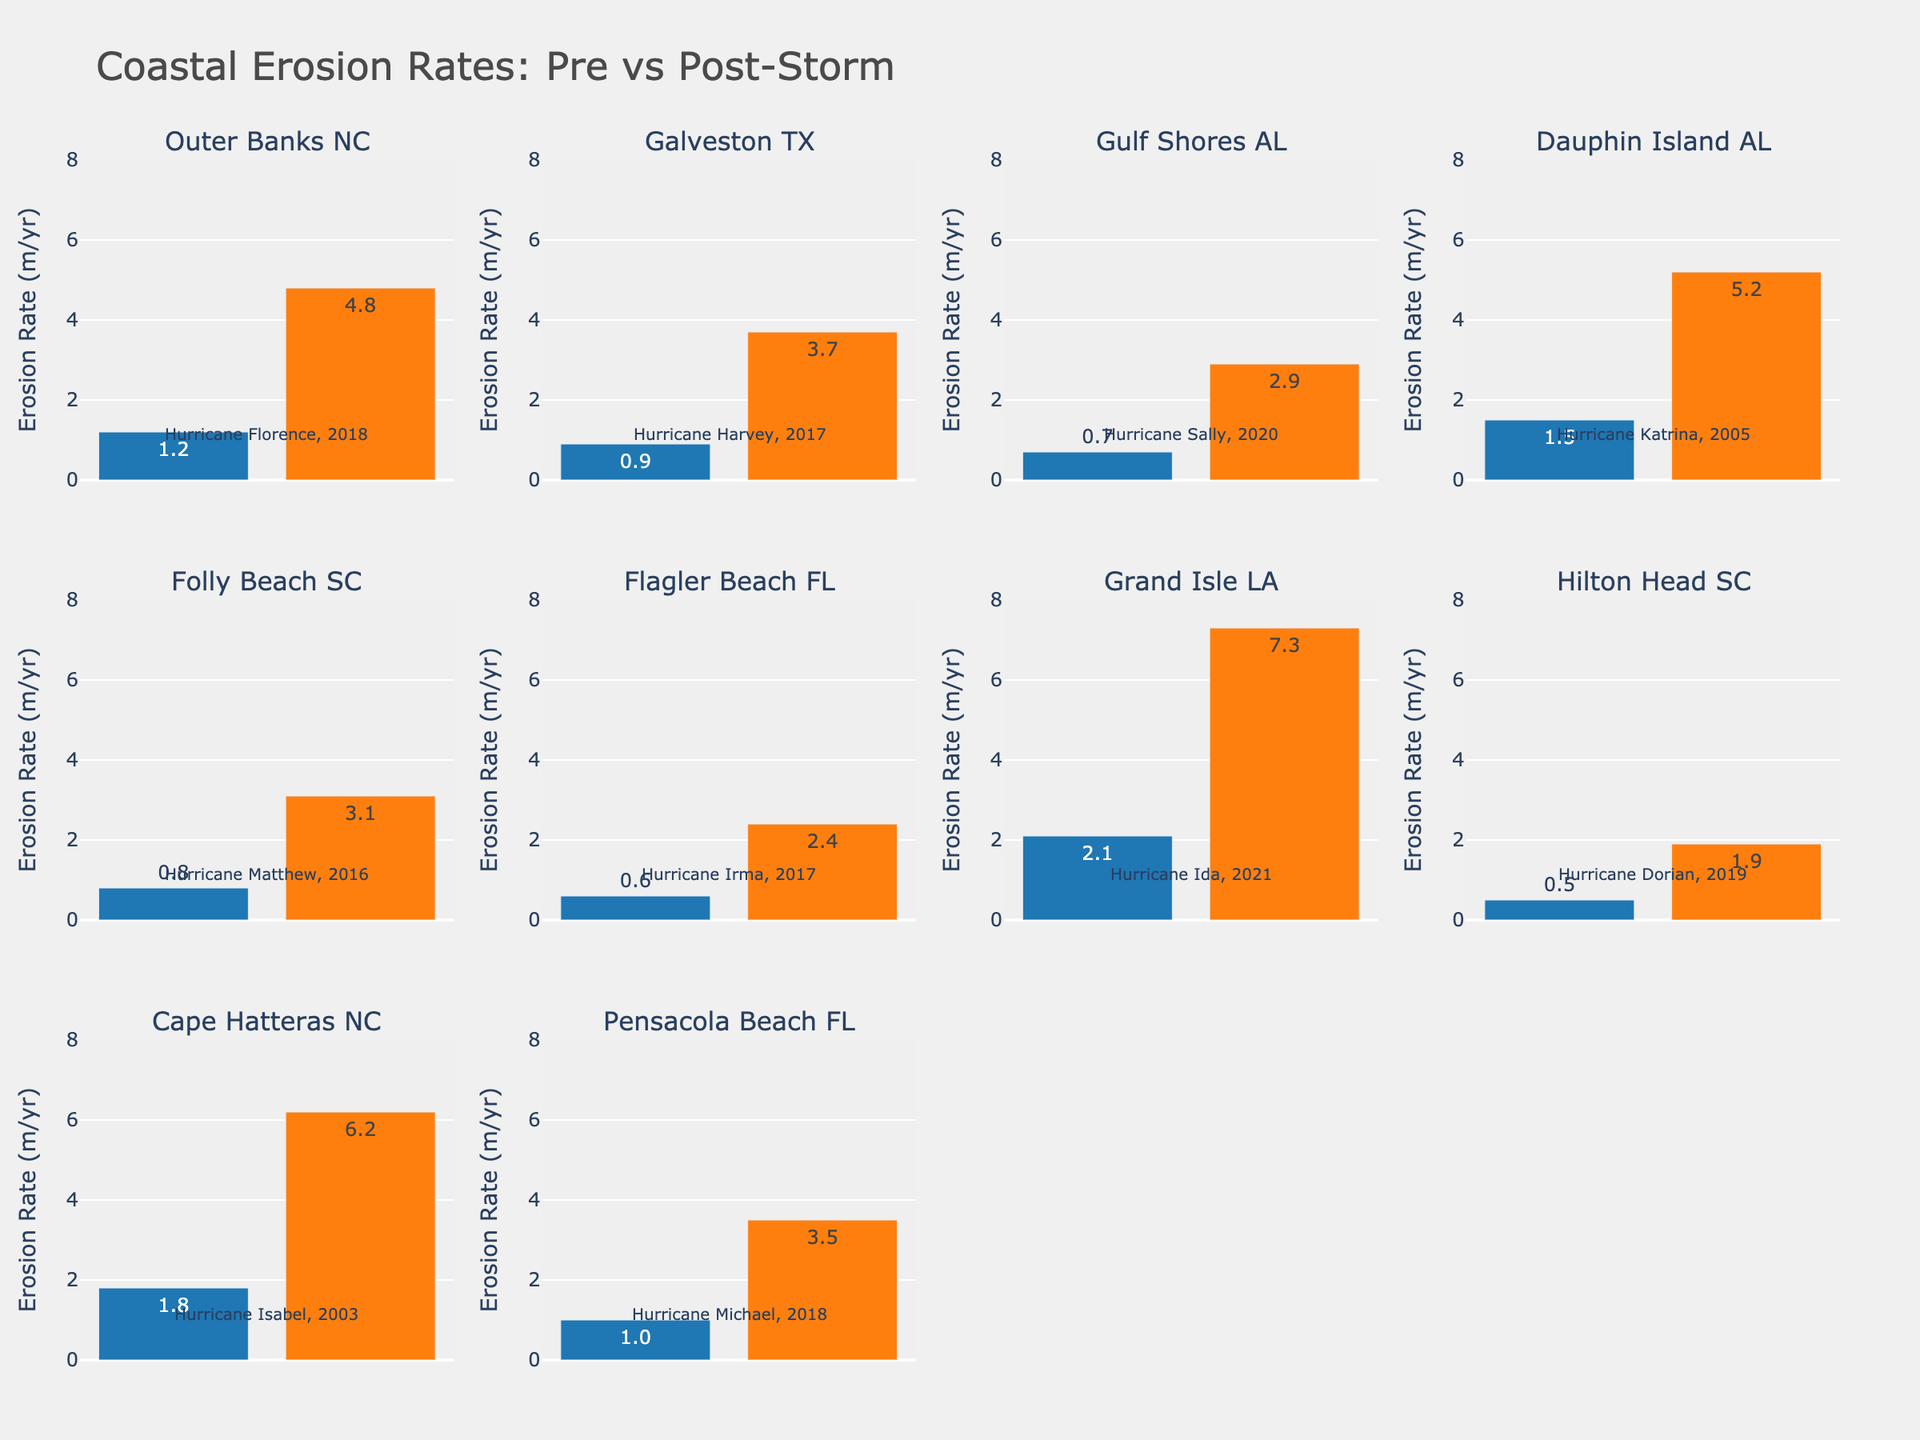Which location shows the highest post-storm erosion rate? Look at the bars representing the post-storm erosion rates in each subplot and identify the tallest bar. Grand Isle, LA shows the highest post-storm erosion rate at 7.3 m/yr.
Answer: Grand Isle, LA What is the average post-storm erosion rate across all locations? Sum all the post-storm erosion rates and divide by the number of locations: (4.8 + 3.7 + 2.9 + 5.2 + 3.1 + 2.4 + 7.3 + 1.9 + 6.2 + 3.5) / 10 = 4.1
Answer: 4.1 Which hurricane resulted in the highest increase in coastal erosion rate? Calculate the increase for each location by subtracting the pre-storm rate from the post-storm rate and identify the maximum: Grand Isle, LA had an increase of 7.3 - 2.1 = 5.2 m/yr.
Answer: Hurricane Ida How much did the erosion rate increase on average across all locations? Calculate the increase for each location, sum them, and divide by the number of locations: [(4.8-1.2) + (3.7-0.9) + (2.9-0.7) + (5.2-1.5) + (3.1-0.8) + (2.4-0.6) + (7.3-2.1) + (1.9-0.5) + (6.2-1.8) + (3.5-1.0)] / 10 = (3.6 + 2.8 + 2.2 + 3.7 + 2.3 + 1.8 + 5.2 + 1.4 + 4.4 + 2.5) / 10 = 2.99
Answer: 2.99 Which hurricane affected two locations in North Carolina? Both subplots for Outer Banks, NC and Cape Hatteras, NC should be checked for their associated hurricanes. Outer Banks, NC was affected by Hurricane Florence and Cape Hatteras, NC was affected by Hurricane Isabel.
Answer: None Which location had the smallest post-storm erosion rate? Look at the bars representing the post-storm erosion rates in each subplot and identify the shortest bar. Hilton Head, SC has the smallest post-storm erosion rate at 1.9 m/yr.
Answer: Hilton Head, SC What has been the trend in erosion rates for hurricane-prone areas when comparing pre- and post-storm values? Compare the heights of pre-storm and post-storm bars across all subplots. Post-storm erosion rates are consistently higher than pre-storm rates, indicating an increasing trend.
Answer: Increasing trend Which location had the smallest change in erosion rate due to the hurricane? Calculate the change for each location (post-storm minus pre-storm) and find the smallest value. Hilton Head, SC had the smallest change: 1.9 - 0.5 = 1.4.
Answer: Hilton Head, SC 